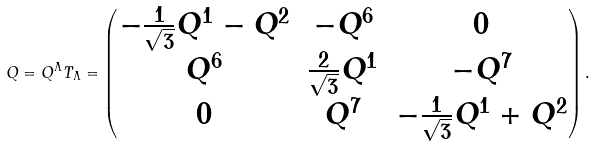<formula> <loc_0><loc_0><loc_500><loc_500>Q = Q ^ { \Lambda } T _ { \Lambda } = \begin{pmatrix} - \frac { 1 } { \sqrt { 3 } } Q ^ { 1 } - Q ^ { 2 } & - Q ^ { 6 } & 0 \\ Q ^ { 6 } & \frac { 2 } { \sqrt { 3 } } Q ^ { 1 } & - Q ^ { 7 } \\ 0 & Q ^ { 7 } & - \frac { 1 } { \sqrt { 3 } } Q ^ { 1 } + Q ^ { 2 } \end{pmatrix} .</formula> 